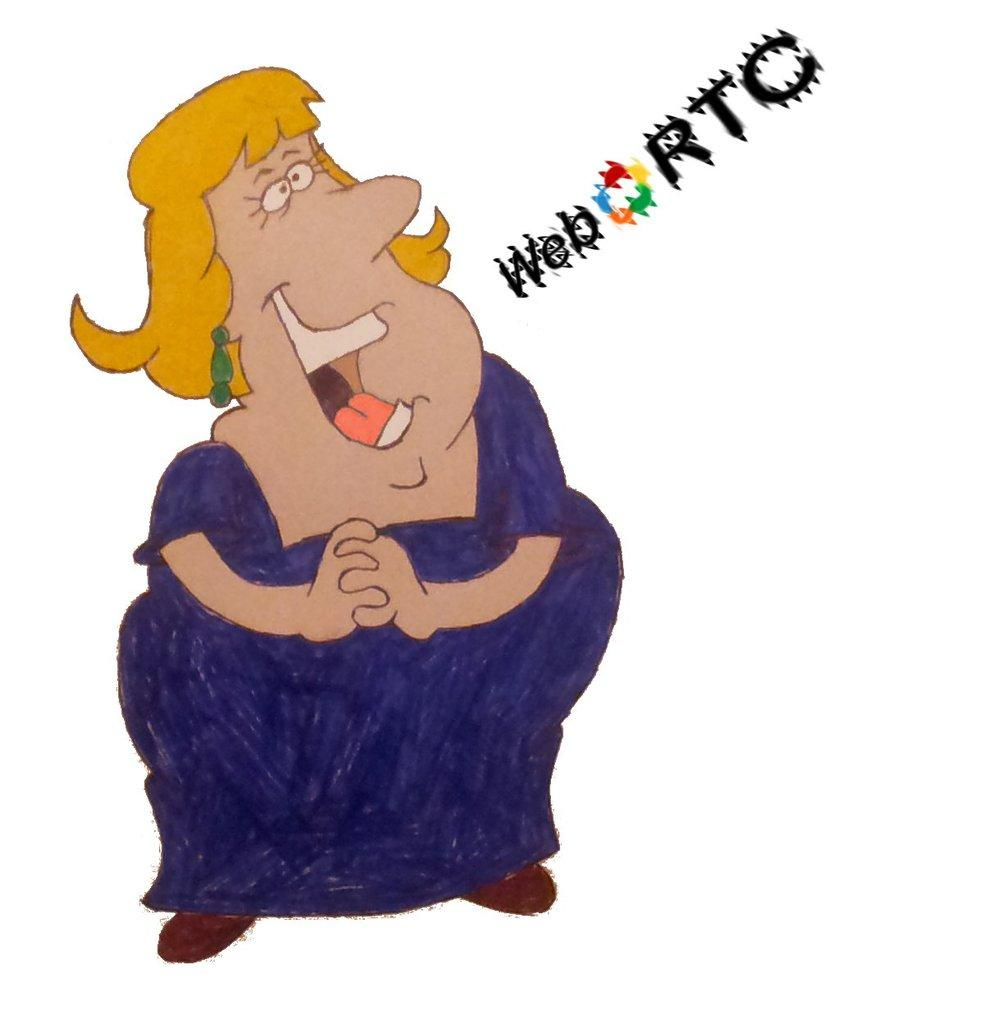What type of character is depicted in the image? There is a cartoon character of a woman in the image. What else can be seen on the right side of the image? There is text written on the right side of the image. What is the color of the background in the image? The background of the image is white. Can you tell me how many strangers are playing with silk in the image? There are no strangers or silk present in the image. 